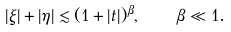Convert formula to latex. <formula><loc_0><loc_0><loc_500><loc_500>| \xi | + | \eta | \lesssim ( 1 + | t | ) ^ { \beta } , \quad \beta \ll 1 .</formula> 